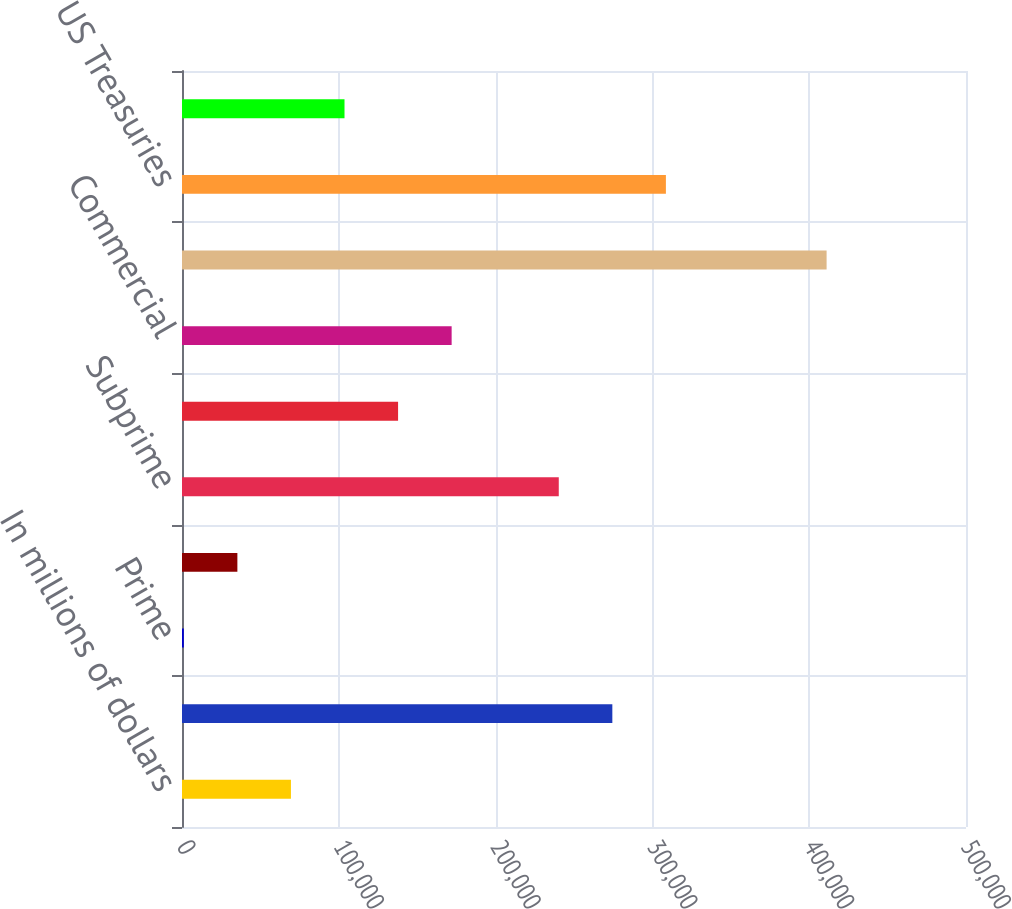<chart> <loc_0><loc_0><loc_500><loc_500><bar_chart><fcel>In millions of dollars<fcel>US government sponsored agency<fcel>Prime<fcel>Alt-A<fcel>Subprime<fcel>Non-US residential<fcel>Commercial<fcel>Total mortgage-backed<fcel>US Treasuries<fcel>Agency and direct obligations<nl><fcel>69479.4<fcel>274450<fcel>1156<fcel>35317.7<fcel>240288<fcel>137803<fcel>171964<fcel>411096<fcel>308611<fcel>103641<nl></chart> 